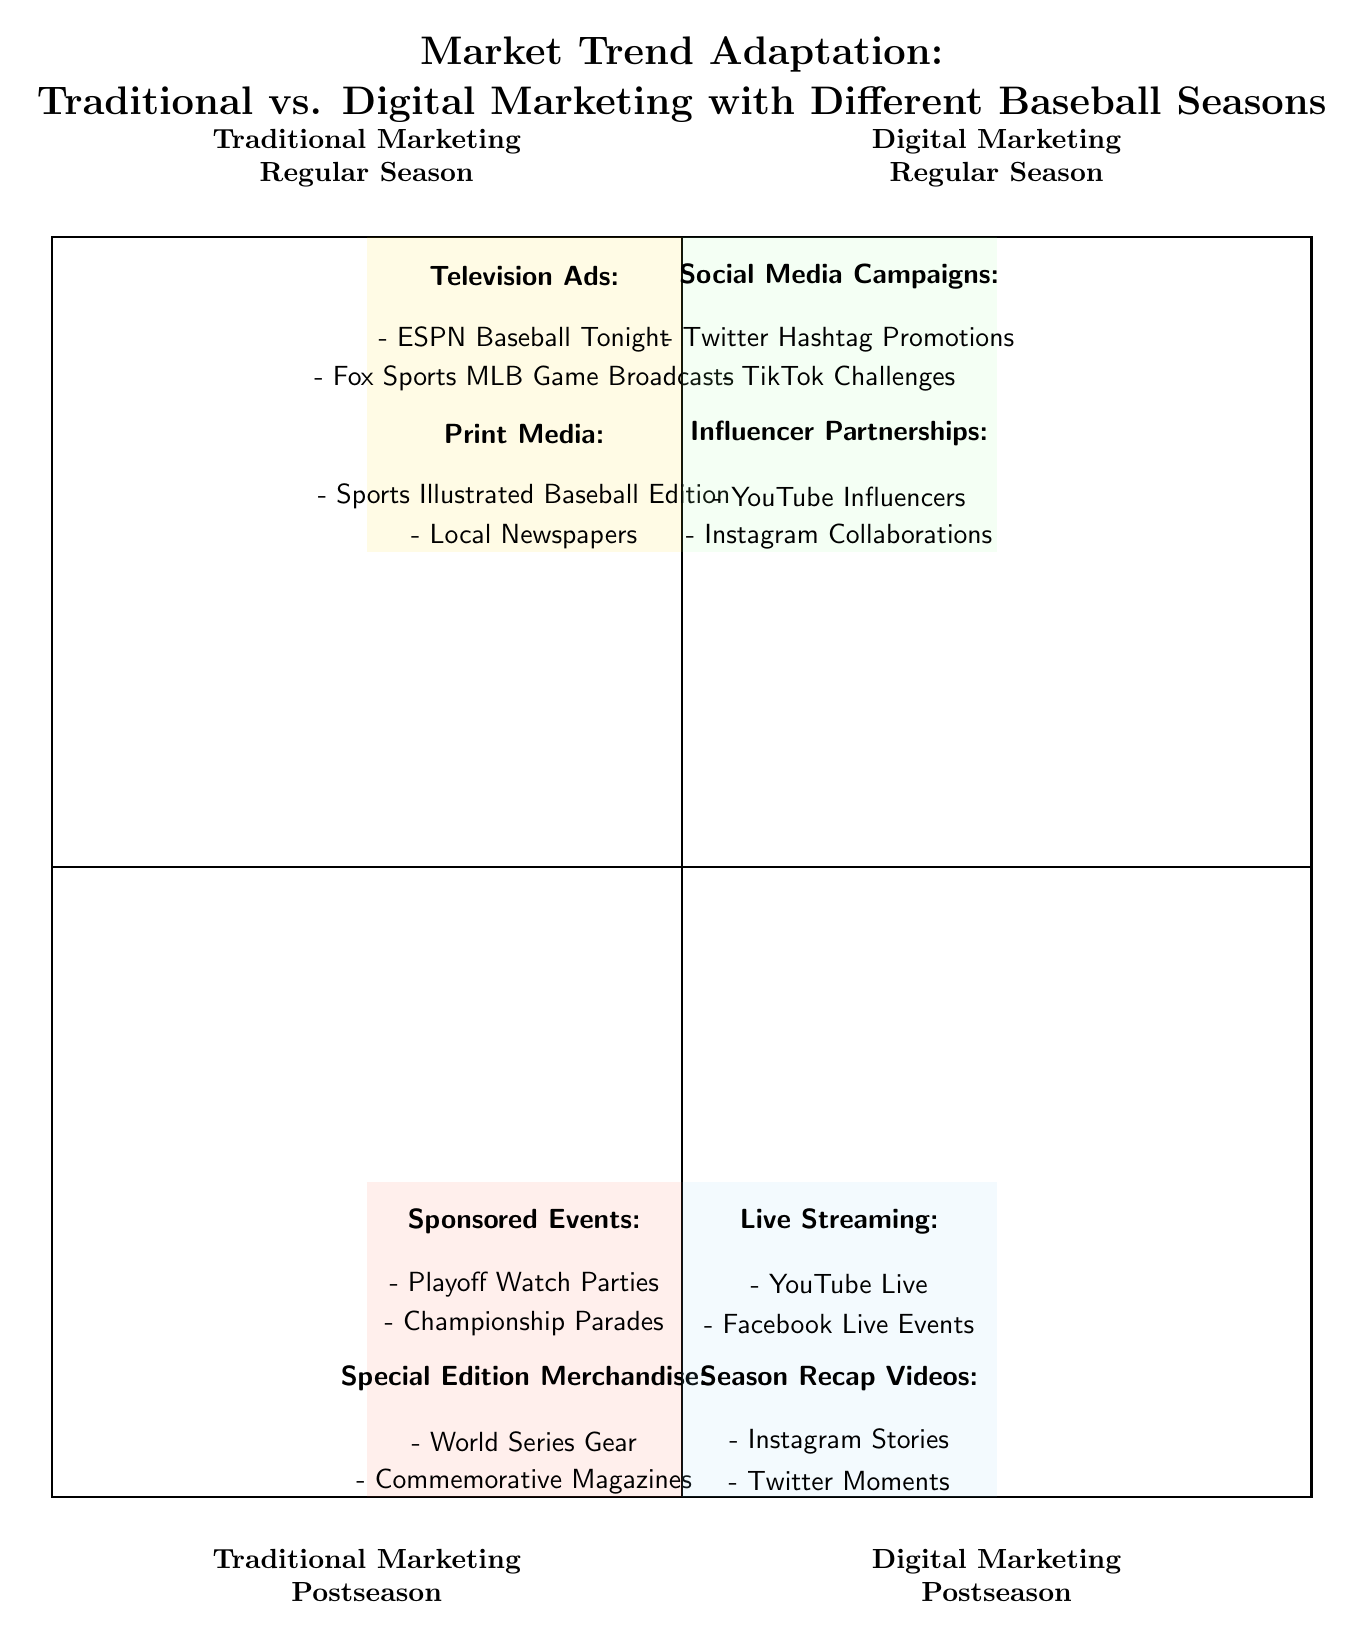What marketing strategy is used in Traditional Marketing - Regular Season? The quadrant for Traditional Marketing - Regular Season lists various strategies such as Television Ads, Print Media, Billboards, and Radio Broadcasts. Hence, any of these may be the answer.
Answer: Television Ads How many strategies are listed in the Digital Marketing - Regular Season quadrant? In the Digital Marketing - Regular Season quadrant, there are a total of four strategies: Social Media Campaigns, Influencer Partnerships, Email Newsletters, and Online Video Ads. Therefore, counting these gives the answer.
Answer: Four Which type of marketing has "Live Streaming" as a strategy? By examining the quadrants, "Live Streaming" is mentioned under the Digital Marketing - Postseason quadrant. Thus, the answer is based on where the strategy appears.
Answer: Digital Marketing - Postseason What examples are provided for Sponsored Events in Traditional Marketing - Postseason? The Traditional Marketing - Postseason quadrant specifies "Playoff Watch Parties" and "Championship Parades" as examples under the Sponsored Events strategy. Therefore, these two specific examples make up the answer.
Answer: Playoff Watch Parties, Championship Parades Is there any overlap between strategies in the Digital Marketing - Regular Season and the Digital Marketing - Postseason? A review of the Digital Marketing strategies in both quadrants reveals that they cover different areas, with none of the specific strategies being repeated. Therefore, the conclusion is that there is no overlap.
Answer: No How many examples are listed under the strategy "In-Game Promotions"? The quadrant for Traditional Marketing - Postseason states there are three examples under In-Game Promotions: Ticket Giveaways and In-Stadium Announcements, along with the heading itself. Therefore, this will give a total of two examples listed under that strategy.
Answer: Two Which quadrant features "Email Newsletters"? "Email Newsletters" can be found within the Digital Marketing - Regular Season quadrant. This determination is made by locating the specific strategy in the appropriate quadrant based on the provided information.
Answer: Digital Marketing - Regular Season What is the primary theme of the diagram? The main focus of the diagram is on how different marketing strategies have adapted in relation to traditional and digital marketing during different baseball seasons, as indicated in the quadrant titles. Thus, this describes the overarching theme.
Answer: Market Trend Adaptation 